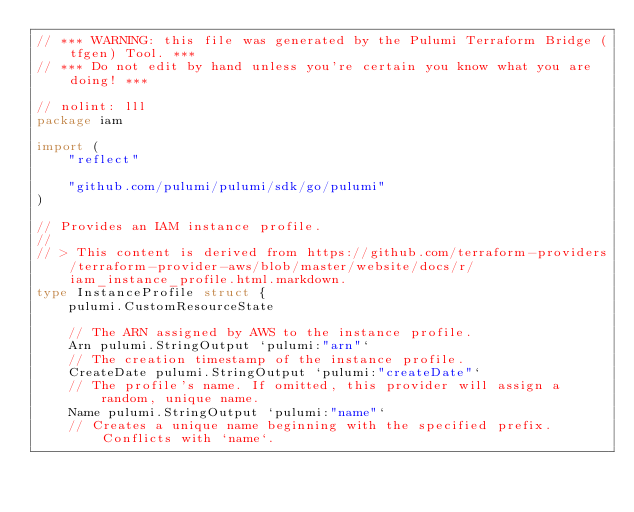Convert code to text. <code><loc_0><loc_0><loc_500><loc_500><_Go_>// *** WARNING: this file was generated by the Pulumi Terraform Bridge (tfgen) Tool. ***
// *** Do not edit by hand unless you're certain you know what you are doing! ***

// nolint: lll
package iam

import (
	"reflect"

	"github.com/pulumi/pulumi/sdk/go/pulumi"
)

// Provides an IAM instance profile.
// 
// > This content is derived from https://github.com/terraform-providers/terraform-provider-aws/blob/master/website/docs/r/iam_instance_profile.html.markdown.
type InstanceProfile struct {
	pulumi.CustomResourceState

	// The ARN assigned by AWS to the instance profile.
	Arn pulumi.StringOutput `pulumi:"arn"`
	// The creation timestamp of the instance profile.
	CreateDate pulumi.StringOutput `pulumi:"createDate"`
	// The profile's name. If omitted, this provider will assign a random, unique name.
	Name pulumi.StringOutput `pulumi:"name"`
	// Creates a unique name beginning with the specified prefix. Conflicts with `name`.</code> 